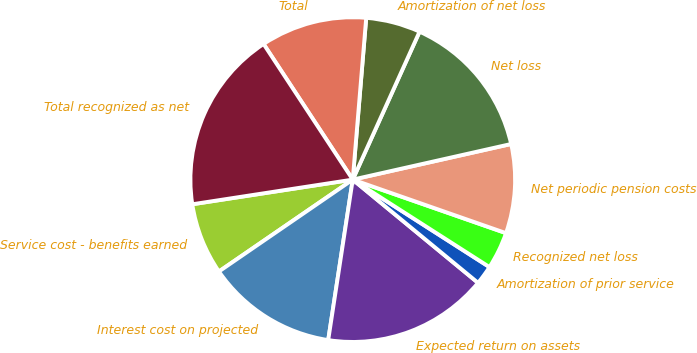Convert chart to OTSL. <chart><loc_0><loc_0><loc_500><loc_500><pie_chart><fcel>Service cost - benefits earned<fcel>Interest cost on projected<fcel>Expected return on assets<fcel>Amortization of prior service<fcel>Recognized net loss<fcel>Net periodic pension costs<fcel>Net loss<fcel>Amortization of net loss<fcel>Total<fcel>Total recognized as net<nl><fcel>7.15%<fcel>13.01%<fcel>16.45%<fcel>1.91%<fcel>3.71%<fcel>8.87%<fcel>14.73%<fcel>5.43%<fcel>10.58%<fcel>18.17%<nl></chart> 